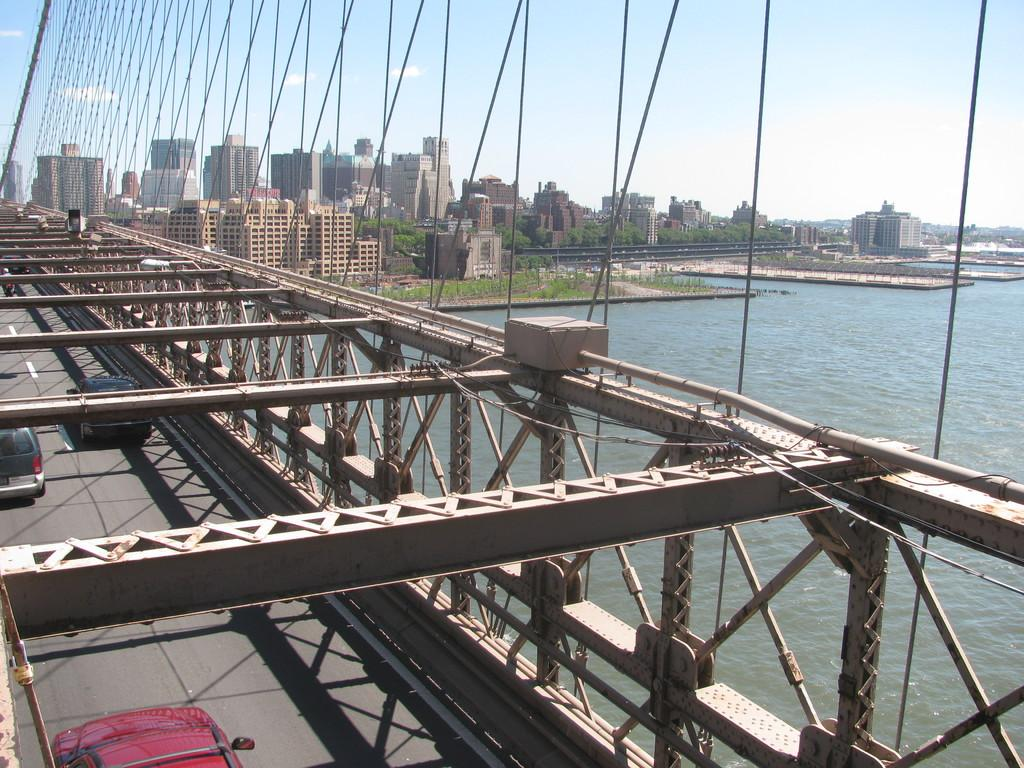What type of natural environment can be seen in the image? Water and grass are visible in the image, indicating a natural environment. What type of man-made structures are present in the image? Buildings and a bridge are visible in the image. What type of transportation can be seen in the image? Vehicles are visible in the image. What is visible in the sky in the image? The sky is visible in the image, and there are clouds present. What type of humor can be seen in the image? There is no humor present in the image; it is a scene of water, grass, buildings, vehicles, the sky, and clouds. What does the queen do in the image? There is no queen present in the image. 